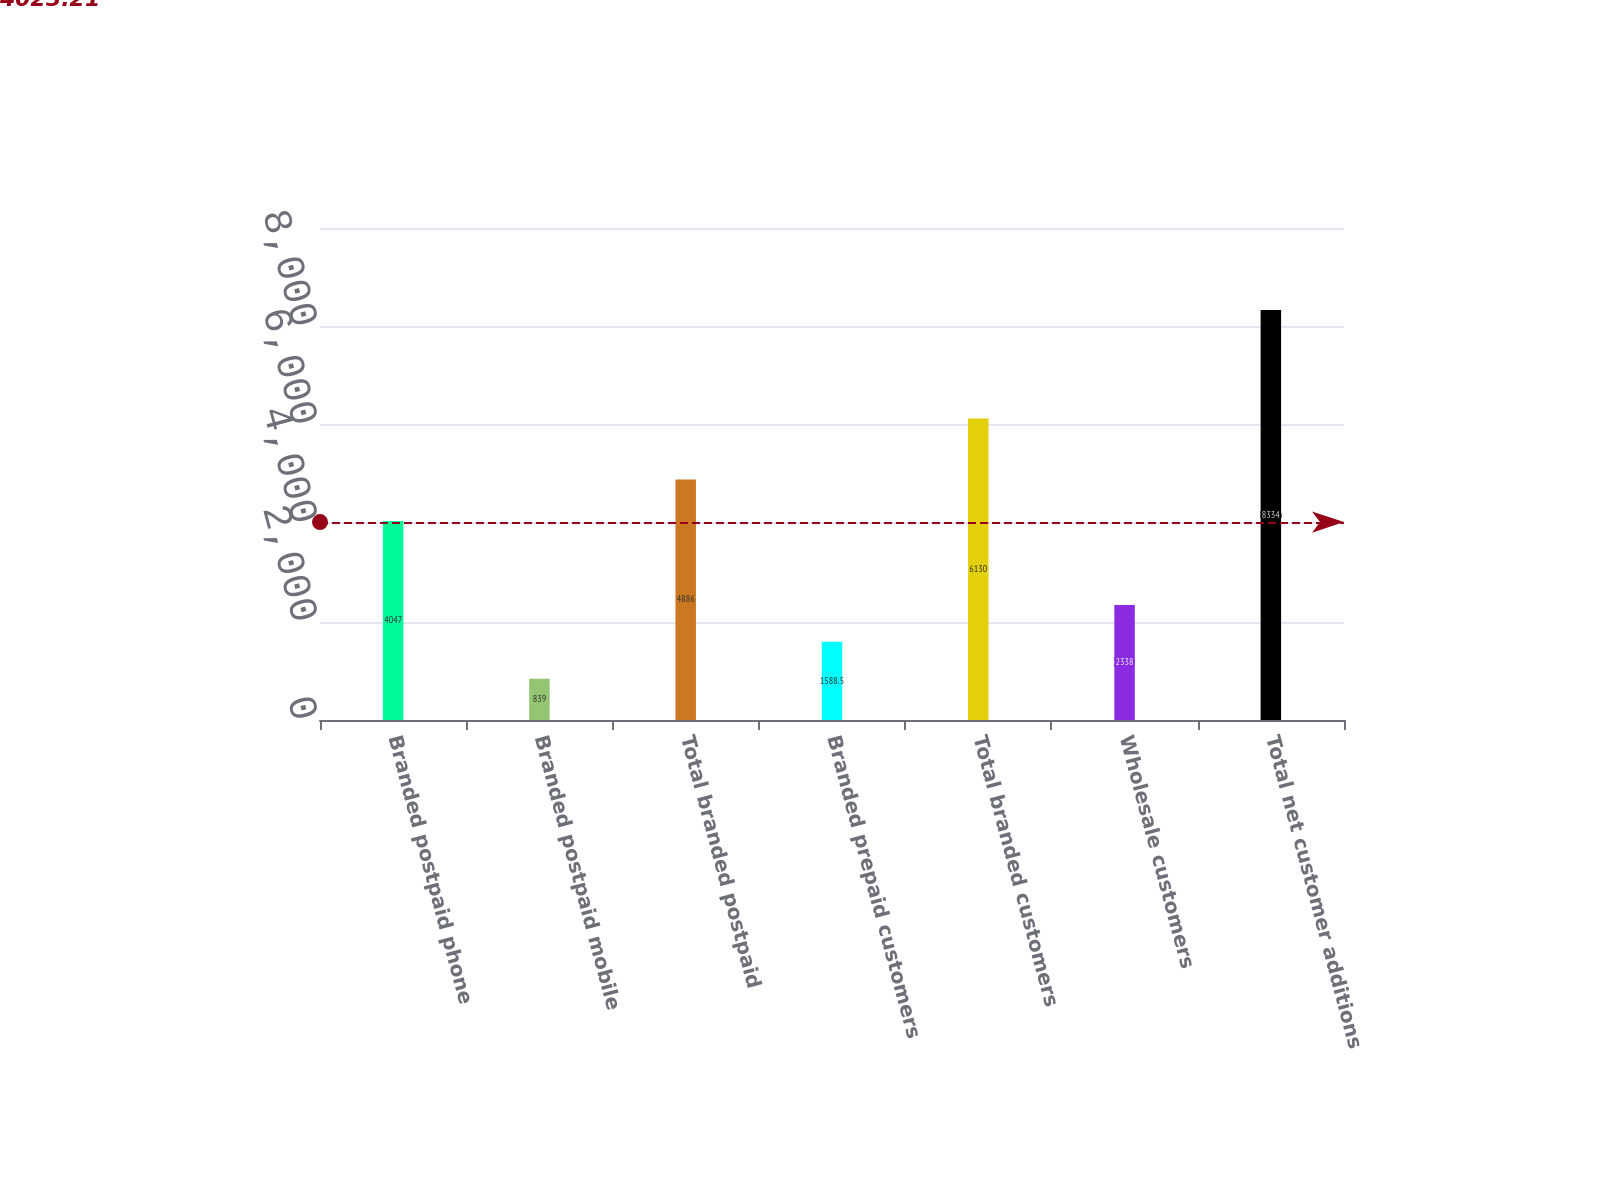Convert chart to OTSL. <chart><loc_0><loc_0><loc_500><loc_500><bar_chart><fcel>Branded postpaid phone<fcel>Branded postpaid mobile<fcel>Total branded postpaid<fcel>Branded prepaid customers<fcel>Total branded customers<fcel>Wholesale customers<fcel>Total net customer additions<nl><fcel>4047<fcel>839<fcel>4886<fcel>1588.5<fcel>6130<fcel>2338<fcel>8334<nl></chart> 